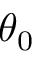Convert formula to latex. <formula><loc_0><loc_0><loc_500><loc_500>\theta _ { 0 }</formula> 